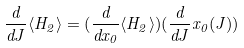Convert formula to latex. <formula><loc_0><loc_0><loc_500><loc_500>\frac { d } { d J } \langle H _ { 2 } \rangle = ( \frac { d } { d x _ { 0 } } \langle H _ { 2 } \rangle ) ( \frac { d } { d J } x _ { 0 } ( J ) )</formula> 